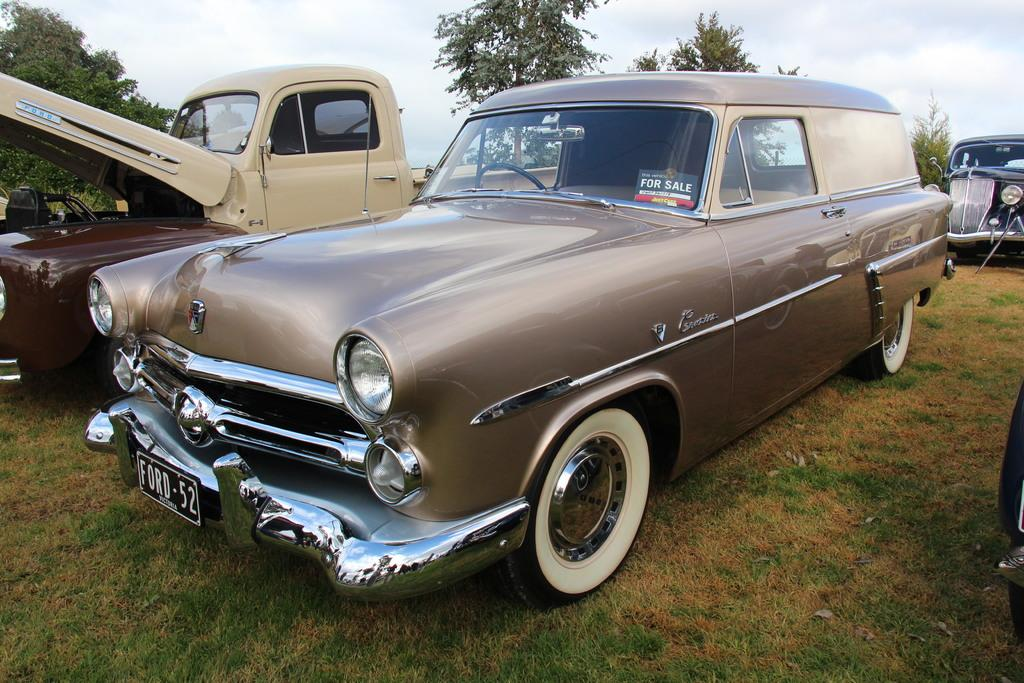<image>
Write a terse but informative summary of the picture. A vintage Ford that is light brown in color with white wall tires parked in the grass. 